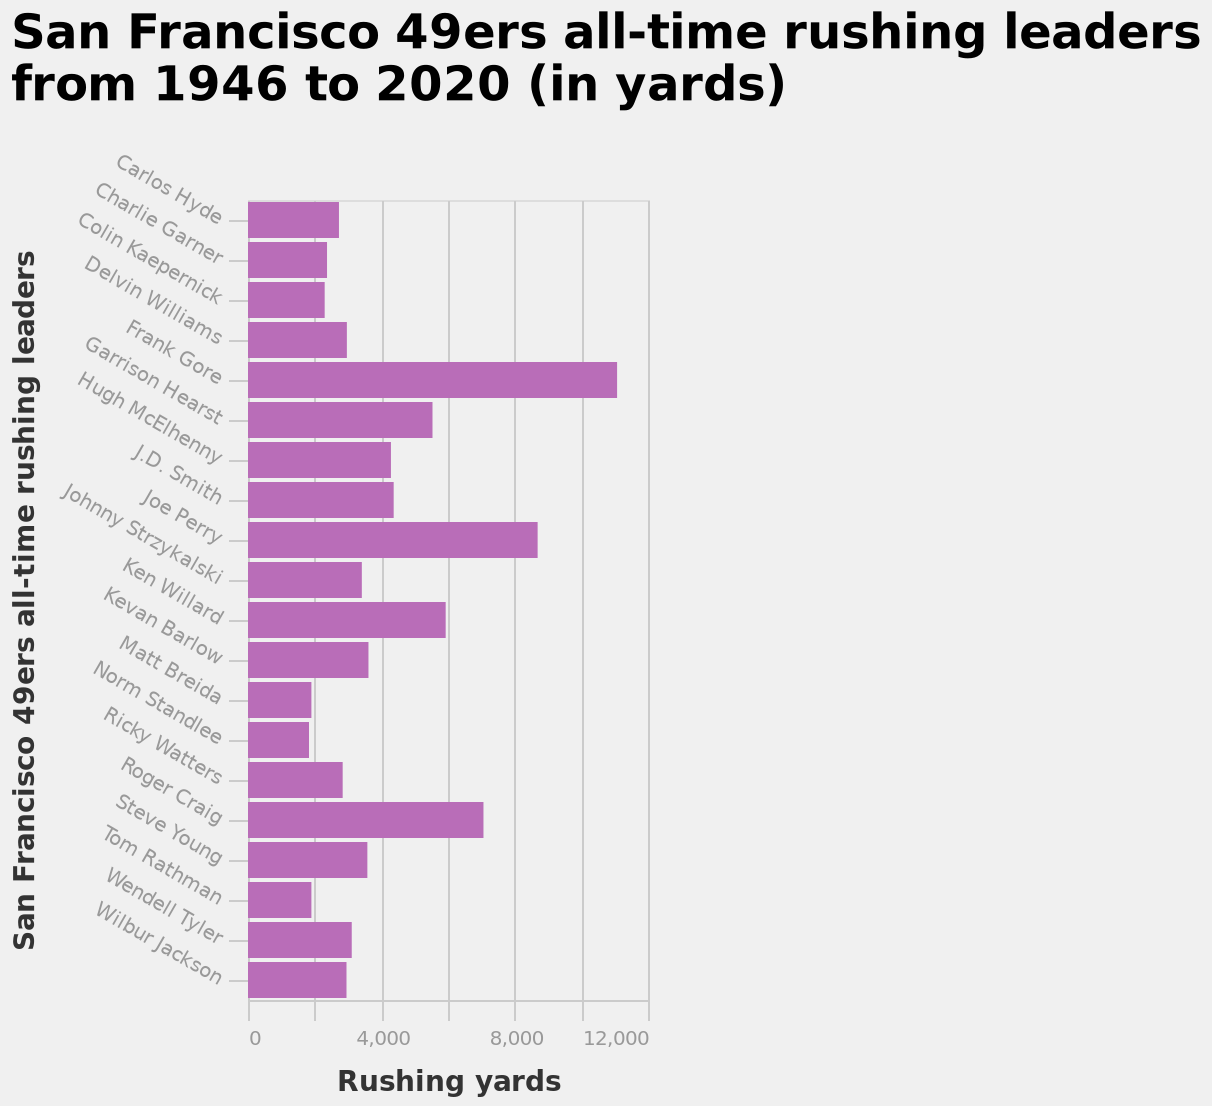<image>
How is the y-axis labeled in the bar diagram? The y-axis is labeled with the names of the San Francisco 49ers all-time rushing leaders from Carlos Hyde to Wilbur Jackson. What is the range of the x-axis in the bar diagram? The x-axis in the bar diagram measures rushing yards on a linear scale ranging from 0 to 12,000. When does the data in the bar diagram span from? The data in the bar diagram spans from 1946 to 2020. How are the San Francisco 49ers all-time rushing leaders plotted on the y-axis of the bar diagram?  The San Francisco 49ers all-time rushing leaders are plotted on the y-axis as a categorical scale from Carlos Hyde to Wilbur Jackson. Offer a thorough analysis of the image. apart from gore perry and craig, the rest of the 49ers are all very much the same. Do Gore Perry and Craig share any similarities with the rest of the 49ers? The description implies that Gore Perry and Craig are different from the rest of the 49ers, suggesting they do not share similarities with the rest of the team. Are the rest of the 49ers all very much different, apart from Gore Perry and Craig? No.apart from gore perry and craig, the rest of the 49ers are all very much the same. 